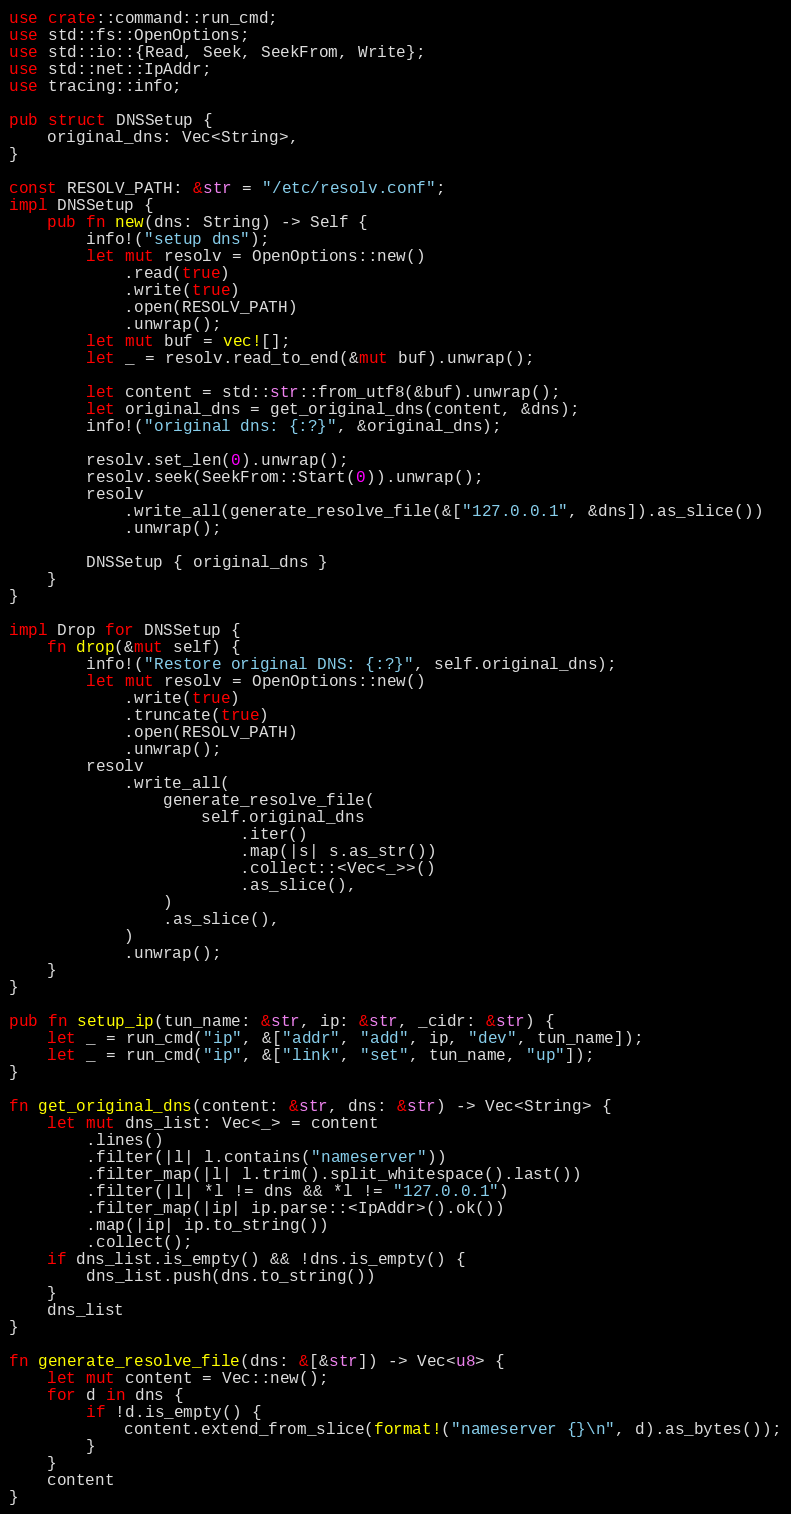Convert code to text. <code><loc_0><loc_0><loc_500><loc_500><_Rust_>use crate::command::run_cmd;
use std::fs::OpenOptions;
use std::io::{Read, Seek, SeekFrom, Write};
use std::net::IpAddr;
use tracing::info;

pub struct DNSSetup {
    original_dns: Vec<String>,
}

const RESOLV_PATH: &str = "/etc/resolv.conf";
impl DNSSetup {
    pub fn new(dns: String) -> Self {
        info!("setup dns");
        let mut resolv = OpenOptions::new()
            .read(true)
            .write(true)
            .open(RESOLV_PATH)
            .unwrap();
        let mut buf = vec![];
        let _ = resolv.read_to_end(&mut buf).unwrap();

        let content = std::str::from_utf8(&buf).unwrap();
        let original_dns = get_original_dns(content, &dns);
        info!("original dns: {:?}", &original_dns);

        resolv.set_len(0).unwrap();
        resolv.seek(SeekFrom::Start(0)).unwrap();
        resolv
            .write_all(generate_resolve_file(&["127.0.0.1", &dns]).as_slice())
            .unwrap();

        DNSSetup { original_dns }
    }
}

impl Drop for DNSSetup {
    fn drop(&mut self) {
        info!("Restore original DNS: {:?}", self.original_dns);
        let mut resolv = OpenOptions::new()
            .write(true)
            .truncate(true)
            .open(RESOLV_PATH)
            .unwrap();
        resolv
            .write_all(
                generate_resolve_file(
                    self.original_dns
                        .iter()
                        .map(|s| s.as_str())
                        .collect::<Vec<_>>()
                        .as_slice(),
                )
                .as_slice(),
            )
            .unwrap();
    }
}

pub fn setup_ip(tun_name: &str, ip: &str, _cidr: &str) {
    let _ = run_cmd("ip", &["addr", "add", ip, "dev", tun_name]);
    let _ = run_cmd("ip", &["link", "set", tun_name, "up"]);
}

fn get_original_dns(content: &str, dns: &str) -> Vec<String> {
    let mut dns_list: Vec<_> = content
        .lines()
        .filter(|l| l.contains("nameserver"))
        .filter_map(|l| l.trim().split_whitespace().last())
        .filter(|l| *l != dns && *l != "127.0.0.1")
        .filter_map(|ip| ip.parse::<IpAddr>().ok())
        .map(|ip| ip.to_string())
        .collect();
    if dns_list.is_empty() && !dns.is_empty() {
        dns_list.push(dns.to_string())
    }
    dns_list
}

fn generate_resolve_file(dns: &[&str]) -> Vec<u8> {
    let mut content = Vec::new();
    for d in dns {
        if !d.is_empty() {
            content.extend_from_slice(format!("nameserver {}\n", d).as_bytes());
        }
    }
    content
}
</code> 